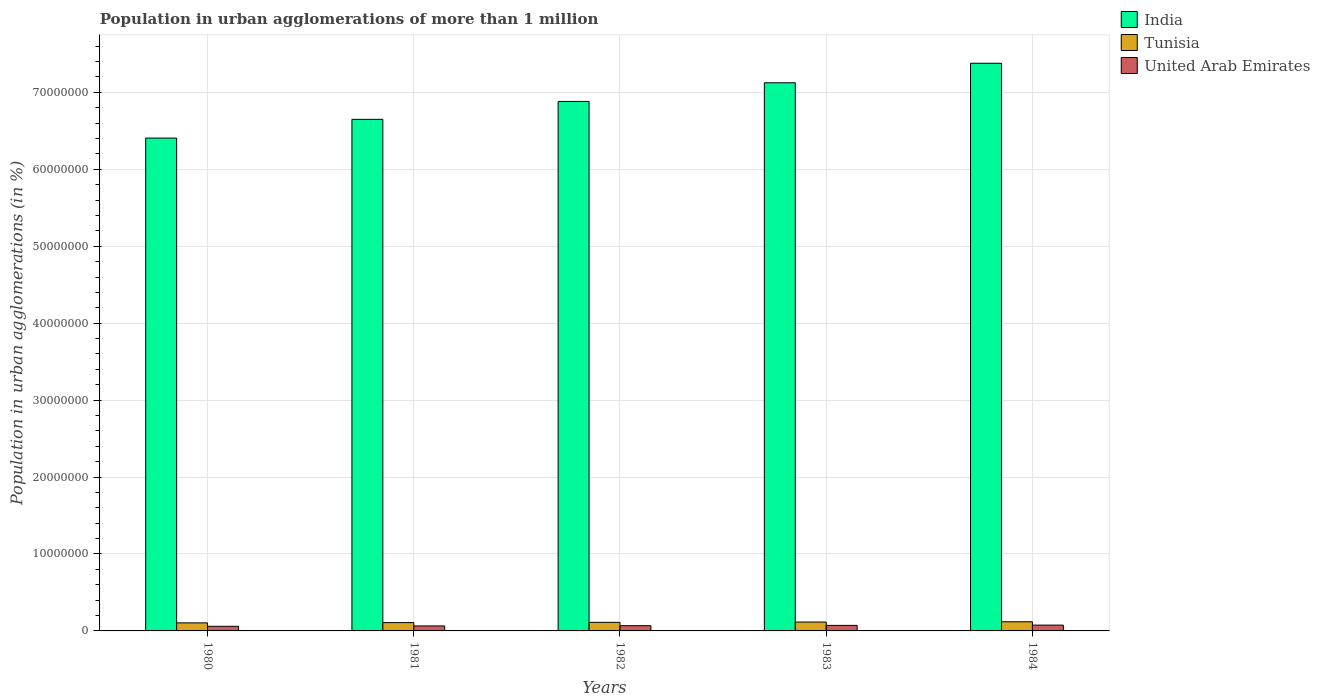How many different coloured bars are there?
Provide a succinct answer. 3. How many groups of bars are there?
Your answer should be compact. 5. What is the label of the 1st group of bars from the left?
Keep it short and to the point. 1980. In how many cases, is the number of bars for a given year not equal to the number of legend labels?
Your answer should be compact. 0. What is the population in urban agglomerations in Tunisia in 1982?
Your answer should be compact. 1.12e+06. Across all years, what is the maximum population in urban agglomerations in United Arab Emirates?
Your response must be concise. 7.54e+05. Across all years, what is the minimum population in urban agglomerations in United Arab Emirates?
Your answer should be compact. 6.00e+05. In which year was the population in urban agglomerations in United Arab Emirates maximum?
Offer a very short reply. 1984. In which year was the population in urban agglomerations in Tunisia minimum?
Offer a terse response. 1980. What is the total population in urban agglomerations in India in the graph?
Your response must be concise. 3.44e+08. What is the difference between the population in urban agglomerations in United Arab Emirates in 1982 and that in 1984?
Keep it short and to the point. -7.17e+04. What is the difference between the population in urban agglomerations in United Arab Emirates in 1981 and the population in urban agglomerations in Tunisia in 1980?
Your answer should be very brief. -3.98e+05. What is the average population in urban agglomerations in United Arab Emirates per year?
Offer a very short reply. 6.80e+05. In the year 1980, what is the difference between the population in urban agglomerations in Tunisia and population in urban agglomerations in United Arab Emirates?
Your answer should be compact. 4.47e+05. What is the ratio of the population in urban agglomerations in United Arab Emirates in 1980 to that in 1983?
Give a very brief answer. 0.84. What is the difference between the highest and the second highest population in urban agglomerations in United Arab Emirates?
Keep it short and to the point. 3.69e+04. What is the difference between the highest and the lowest population in urban agglomerations in Tunisia?
Give a very brief answer. 1.44e+05. In how many years, is the population in urban agglomerations in India greater than the average population in urban agglomerations in India taken over all years?
Provide a succinct answer. 2. Is the sum of the population in urban agglomerations in Tunisia in 1981 and 1982 greater than the maximum population in urban agglomerations in United Arab Emirates across all years?
Make the answer very short. Yes. What does the 2nd bar from the left in 1982 represents?
Offer a very short reply. Tunisia. What does the 1st bar from the right in 1983 represents?
Provide a succinct answer. United Arab Emirates. How many bars are there?
Keep it short and to the point. 15. What is the difference between two consecutive major ticks on the Y-axis?
Keep it short and to the point. 1.00e+07. Does the graph contain grids?
Your answer should be compact. Yes. How are the legend labels stacked?
Give a very brief answer. Vertical. What is the title of the graph?
Provide a short and direct response. Population in urban agglomerations of more than 1 million. Does "Swaziland" appear as one of the legend labels in the graph?
Give a very brief answer. No. What is the label or title of the X-axis?
Provide a succinct answer. Years. What is the label or title of the Y-axis?
Ensure brevity in your answer.  Population in urban agglomerations (in %). What is the Population in urban agglomerations (in %) in India in 1980?
Ensure brevity in your answer.  6.41e+07. What is the Population in urban agglomerations (in %) of Tunisia in 1980?
Provide a short and direct response. 1.05e+06. What is the Population in urban agglomerations (in %) of United Arab Emirates in 1980?
Make the answer very short. 6.00e+05. What is the Population in urban agglomerations (in %) in India in 1981?
Keep it short and to the point. 6.65e+07. What is the Population in urban agglomerations (in %) in Tunisia in 1981?
Provide a succinct answer. 1.08e+06. What is the Population in urban agglomerations (in %) of United Arab Emirates in 1981?
Your answer should be very brief. 6.49e+05. What is the Population in urban agglomerations (in %) of India in 1982?
Keep it short and to the point. 6.88e+07. What is the Population in urban agglomerations (in %) of Tunisia in 1982?
Your answer should be compact. 1.12e+06. What is the Population in urban agglomerations (in %) in United Arab Emirates in 1982?
Ensure brevity in your answer.  6.82e+05. What is the Population in urban agglomerations (in %) of India in 1983?
Keep it short and to the point. 7.12e+07. What is the Population in urban agglomerations (in %) of Tunisia in 1983?
Provide a succinct answer. 1.15e+06. What is the Population in urban agglomerations (in %) of United Arab Emirates in 1983?
Provide a succinct answer. 7.17e+05. What is the Population in urban agglomerations (in %) in India in 1984?
Your answer should be very brief. 7.38e+07. What is the Population in urban agglomerations (in %) in Tunisia in 1984?
Your answer should be compact. 1.19e+06. What is the Population in urban agglomerations (in %) of United Arab Emirates in 1984?
Your response must be concise. 7.54e+05. Across all years, what is the maximum Population in urban agglomerations (in %) of India?
Make the answer very short. 7.38e+07. Across all years, what is the maximum Population in urban agglomerations (in %) in Tunisia?
Give a very brief answer. 1.19e+06. Across all years, what is the maximum Population in urban agglomerations (in %) in United Arab Emirates?
Provide a short and direct response. 7.54e+05. Across all years, what is the minimum Population in urban agglomerations (in %) in India?
Offer a terse response. 6.41e+07. Across all years, what is the minimum Population in urban agglomerations (in %) of Tunisia?
Ensure brevity in your answer.  1.05e+06. Across all years, what is the minimum Population in urban agglomerations (in %) of United Arab Emirates?
Your answer should be compact. 6.00e+05. What is the total Population in urban agglomerations (in %) in India in the graph?
Offer a terse response. 3.44e+08. What is the total Population in urban agglomerations (in %) of Tunisia in the graph?
Make the answer very short. 5.59e+06. What is the total Population in urban agglomerations (in %) of United Arab Emirates in the graph?
Offer a very short reply. 3.40e+06. What is the difference between the Population in urban agglomerations (in %) of India in 1980 and that in 1981?
Offer a very short reply. -2.43e+06. What is the difference between the Population in urban agglomerations (in %) in Tunisia in 1980 and that in 1981?
Your answer should be very brief. -3.39e+04. What is the difference between the Population in urban agglomerations (in %) of United Arab Emirates in 1980 and that in 1981?
Give a very brief answer. -4.88e+04. What is the difference between the Population in urban agglomerations (in %) in India in 1980 and that in 1982?
Ensure brevity in your answer.  -4.76e+06. What is the difference between the Population in urban agglomerations (in %) of Tunisia in 1980 and that in 1982?
Your response must be concise. -6.89e+04. What is the difference between the Population in urban agglomerations (in %) in United Arab Emirates in 1980 and that in 1982?
Your response must be concise. -8.18e+04. What is the difference between the Population in urban agglomerations (in %) of India in 1980 and that in 1983?
Make the answer very short. -7.19e+06. What is the difference between the Population in urban agglomerations (in %) in Tunisia in 1980 and that in 1983?
Keep it short and to the point. -1.05e+05. What is the difference between the Population in urban agglomerations (in %) in United Arab Emirates in 1980 and that in 1983?
Keep it short and to the point. -1.17e+05. What is the difference between the Population in urban agglomerations (in %) of India in 1980 and that in 1984?
Provide a succinct answer. -9.72e+06. What is the difference between the Population in urban agglomerations (in %) in Tunisia in 1980 and that in 1984?
Offer a terse response. -1.44e+05. What is the difference between the Population in urban agglomerations (in %) in United Arab Emirates in 1980 and that in 1984?
Your response must be concise. -1.54e+05. What is the difference between the Population in urban agglomerations (in %) in India in 1981 and that in 1982?
Provide a succinct answer. -2.33e+06. What is the difference between the Population in urban agglomerations (in %) in Tunisia in 1981 and that in 1982?
Provide a short and direct response. -3.50e+04. What is the difference between the Population in urban agglomerations (in %) of United Arab Emirates in 1981 and that in 1982?
Offer a terse response. -3.30e+04. What is the difference between the Population in urban agglomerations (in %) in India in 1981 and that in 1983?
Provide a short and direct response. -4.75e+06. What is the difference between the Population in urban agglomerations (in %) in Tunisia in 1981 and that in 1983?
Offer a terse response. -7.12e+04. What is the difference between the Population in urban agglomerations (in %) of United Arab Emirates in 1981 and that in 1983?
Offer a very short reply. -6.79e+04. What is the difference between the Population in urban agglomerations (in %) of India in 1981 and that in 1984?
Your answer should be very brief. -7.29e+06. What is the difference between the Population in urban agglomerations (in %) in Tunisia in 1981 and that in 1984?
Keep it short and to the point. -1.10e+05. What is the difference between the Population in urban agglomerations (in %) in United Arab Emirates in 1981 and that in 1984?
Give a very brief answer. -1.05e+05. What is the difference between the Population in urban agglomerations (in %) of India in 1982 and that in 1983?
Your answer should be compact. -2.43e+06. What is the difference between the Population in urban agglomerations (in %) of Tunisia in 1982 and that in 1983?
Provide a short and direct response. -3.62e+04. What is the difference between the Population in urban agglomerations (in %) of United Arab Emirates in 1982 and that in 1983?
Offer a very short reply. -3.48e+04. What is the difference between the Population in urban agglomerations (in %) in India in 1982 and that in 1984?
Ensure brevity in your answer.  -4.96e+06. What is the difference between the Population in urban agglomerations (in %) of Tunisia in 1982 and that in 1984?
Provide a succinct answer. -7.46e+04. What is the difference between the Population in urban agglomerations (in %) of United Arab Emirates in 1982 and that in 1984?
Ensure brevity in your answer.  -7.17e+04. What is the difference between the Population in urban agglomerations (in %) of India in 1983 and that in 1984?
Keep it short and to the point. -2.53e+06. What is the difference between the Population in urban agglomerations (in %) of Tunisia in 1983 and that in 1984?
Keep it short and to the point. -3.84e+04. What is the difference between the Population in urban agglomerations (in %) in United Arab Emirates in 1983 and that in 1984?
Give a very brief answer. -3.69e+04. What is the difference between the Population in urban agglomerations (in %) of India in 1980 and the Population in urban agglomerations (in %) of Tunisia in 1981?
Ensure brevity in your answer.  6.30e+07. What is the difference between the Population in urban agglomerations (in %) of India in 1980 and the Population in urban agglomerations (in %) of United Arab Emirates in 1981?
Your answer should be compact. 6.34e+07. What is the difference between the Population in urban agglomerations (in %) of Tunisia in 1980 and the Population in urban agglomerations (in %) of United Arab Emirates in 1981?
Offer a very short reply. 3.98e+05. What is the difference between the Population in urban agglomerations (in %) of India in 1980 and the Population in urban agglomerations (in %) of Tunisia in 1982?
Your answer should be compact. 6.29e+07. What is the difference between the Population in urban agglomerations (in %) in India in 1980 and the Population in urban agglomerations (in %) in United Arab Emirates in 1982?
Offer a terse response. 6.34e+07. What is the difference between the Population in urban agglomerations (in %) in Tunisia in 1980 and the Population in urban agglomerations (in %) in United Arab Emirates in 1982?
Your answer should be very brief. 3.65e+05. What is the difference between the Population in urban agglomerations (in %) of India in 1980 and the Population in urban agglomerations (in %) of Tunisia in 1983?
Your response must be concise. 6.29e+07. What is the difference between the Population in urban agglomerations (in %) in India in 1980 and the Population in urban agglomerations (in %) in United Arab Emirates in 1983?
Your answer should be compact. 6.33e+07. What is the difference between the Population in urban agglomerations (in %) of Tunisia in 1980 and the Population in urban agglomerations (in %) of United Arab Emirates in 1983?
Provide a succinct answer. 3.30e+05. What is the difference between the Population in urban agglomerations (in %) in India in 1980 and the Population in urban agglomerations (in %) in Tunisia in 1984?
Offer a terse response. 6.29e+07. What is the difference between the Population in urban agglomerations (in %) in India in 1980 and the Population in urban agglomerations (in %) in United Arab Emirates in 1984?
Your response must be concise. 6.33e+07. What is the difference between the Population in urban agglomerations (in %) of Tunisia in 1980 and the Population in urban agglomerations (in %) of United Arab Emirates in 1984?
Ensure brevity in your answer.  2.93e+05. What is the difference between the Population in urban agglomerations (in %) of India in 1981 and the Population in urban agglomerations (in %) of Tunisia in 1982?
Make the answer very short. 6.54e+07. What is the difference between the Population in urban agglomerations (in %) of India in 1981 and the Population in urban agglomerations (in %) of United Arab Emirates in 1982?
Keep it short and to the point. 6.58e+07. What is the difference between the Population in urban agglomerations (in %) of Tunisia in 1981 and the Population in urban agglomerations (in %) of United Arab Emirates in 1982?
Offer a very short reply. 3.99e+05. What is the difference between the Population in urban agglomerations (in %) in India in 1981 and the Population in urban agglomerations (in %) in Tunisia in 1983?
Your answer should be very brief. 6.53e+07. What is the difference between the Population in urban agglomerations (in %) of India in 1981 and the Population in urban agglomerations (in %) of United Arab Emirates in 1983?
Offer a very short reply. 6.58e+07. What is the difference between the Population in urban agglomerations (in %) in Tunisia in 1981 and the Population in urban agglomerations (in %) in United Arab Emirates in 1983?
Keep it short and to the point. 3.64e+05. What is the difference between the Population in urban agglomerations (in %) in India in 1981 and the Population in urban agglomerations (in %) in Tunisia in 1984?
Give a very brief answer. 6.53e+07. What is the difference between the Population in urban agglomerations (in %) of India in 1981 and the Population in urban agglomerations (in %) of United Arab Emirates in 1984?
Ensure brevity in your answer.  6.57e+07. What is the difference between the Population in urban agglomerations (in %) of Tunisia in 1981 and the Population in urban agglomerations (in %) of United Arab Emirates in 1984?
Make the answer very short. 3.27e+05. What is the difference between the Population in urban agglomerations (in %) in India in 1982 and the Population in urban agglomerations (in %) in Tunisia in 1983?
Offer a terse response. 6.77e+07. What is the difference between the Population in urban agglomerations (in %) in India in 1982 and the Population in urban agglomerations (in %) in United Arab Emirates in 1983?
Your answer should be compact. 6.81e+07. What is the difference between the Population in urban agglomerations (in %) of Tunisia in 1982 and the Population in urban agglomerations (in %) of United Arab Emirates in 1983?
Your response must be concise. 3.99e+05. What is the difference between the Population in urban agglomerations (in %) in India in 1982 and the Population in urban agglomerations (in %) in Tunisia in 1984?
Your answer should be compact. 6.76e+07. What is the difference between the Population in urban agglomerations (in %) in India in 1982 and the Population in urban agglomerations (in %) in United Arab Emirates in 1984?
Your answer should be very brief. 6.81e+07. What is the difference between the Population in urban agglomerations (in %) in Tunisia in 1982 and the Population in urban agglomerations (in %) in United Arab Emirates in 1984?
Your answer should be compact. 3.62e+05. What is the difference between the Population in urban agglomerations (in %) in India in 1983 and the Population in urban agglomerations (in %) in Tunisia in 1984?
Make the answer very short. 7.01e+07. What is the difference between the Population in urban agglomerations (in %) in India in 1983 and the Population in urban agglomerations (in %) in United Arab Emirates in 1984?
Your response must be concise. 7.05e+07. What is the difference between the Population in urban agglomerations (in %) in Tunisia in 1983 and the Population in urban agglomerations (in %) in United Arab Emirates in 1984?
Your response must be concise. 3.99e+05. What is the average Population in urban agglomerations (in %) in India per year?
Make the answer very short. 6.89e+07. What is the average Population in urban agglomerations (in %) in Tunisia per year?
Offer a very short reply. 1.12e+06. What is the average Population in urban agglomerations (in %) in United Arab Emirates per year?
Your answer should be compact. 6.80e+05. In the year 1980, what is the difference between the Population in urban agglomerations (in %) in India and Population in urban agglomerations (in %) in Tunisia?
Your response must be concise. 6.30e+07. In the year 1980, what is the difference between the Population in urban agglomerations (in %) in India and Population in urban agglomerations (in %) in United Arab Emirates?
Offer a terse response. 6.35e+07. In the year 1980, what is the difference between the Population in urban agglomerations (in %) of Tunisia and Population in urban agglomerations (in %) of United Arab Emirates?
Provide a succinct answer. 4.47e+05. In the year 1981, what is the difference between the Population in urban agglomerations (in %) of India and Population in urban agglomerations (in %) of Tunisia?
Give a very brief answer. 6.54e+07. In the year 1981, what is the difference between the Population in urban agglomerations (in %) in India and Population in urban agglomerations (in %) in United Arab Emirates?
Your response must be concise. 6.58e+07. In the year 1981, what is the difference between the Population in urban agglomerations (in %) in Tunisia and Population in urban agglomerations (in %) in United Arab Emirates?
Keep it short and to the point. 4.32e+05. In the year 1982, what is the difference between the Population in urban agglomerations (in %) of India and Population in urban agglomerations (in %) of Tunisia?
Offer a very short reply. 6.77e+07. In the year 1982, what is the difference between the Population in urban agglomerations (in %) of India and Population in urban agglomerations (in %) of United Arab Emirates?
Your answer should be compact. 6.81e+07. In the year 1982, what is the difference between the Population in urban agglomerations (in %) in Tunisia and Population in urban agglomerations (in %) in United Arab Emirates?
Offer a terse response. 4.34e+05. In the year 1983, what is the difference between the Population in urban agglomerations (in %) of India and Population in urban agglomerations (in %) of Tunisia?
Provide a short and direct response. 7.01e+07. In the year 1983, what is the difference between the Population in urban agglomerations (in %) in India and Population in urban agglomerations (in %) in United Arab Emirates?
Keep it short and to the point. 7.05e+07. In the year 1983, what is the difference between the Population in urban agglomerations (in %) in Tunisia and Population in urban agglomerations (in %) in United Arab Emirates?
Your answer should be very brief. 4.35e+05. In the year 1984, what is the difference between the Population in urban agglomerations (in %) of India and Population in urban agglomerations (in %) of Tunisia?
Ensure brevity in your answer.  7.26e+07. In the year 1984, what is the difference between the Population in urban agglomerations (in %) of India and Population in urban agglomerations (in %) of United Arab Emirates?
Offer a very short reply. 7.30e+07. In the year 1984, what is the difference between the Population in urban agglomerations (in %) of Tunisia and Population in urban agglomerations (in %) of United Arab Emirates?
Offer a very short reply. 4.37e+05. What is the ratio of the Population in urban agglomerations (in %) in India in 1980 to that in 1981?
Keep it short and to the point. 0.96. What is the ratio of the Population in urban agglomerations (in %) in Tunisia in 1980 to that in 1981?
Make the answer very short. 0.97. What is the ratio of the Population in urban agglomerations (in %) of United Arab Emirates in 1980 to that in 1981?
Offer a very short reply. 0.92. What is the ratio of the Population in urban agglomerations (in %) in India in 1980 to that in 1982?
Provide a succinct answer. 0.93. What is the ratio of the Population in urban agglomerations (in %) in Tunisia in 1980 to that in 1982?
Give a very brief answer. 0.94. What is the ratio of the Population in urban agglomerations (in %) of United Arab Emirates in 1980 to that in 1982?
Make the answer very short. 0.88. What is the ratio of the Population in urban agglomerations (in %) of India in 1980 to that in 1983?
Your answer should be very brief. 0.9. What is the ratio of the Population in urban agglomerations (in %) of Tunisia in 1980 to that in 1983?
Provide a succinct answer. 0.91. What is the ratio of the Population in urban agglomerations (in %) of United Arab Emirates in 1980 to that in 1983?
Provide a succinct answer. 0.84. What is the ratio of the Population in urban agglomerations (in %) in India in 1980 to that in 1984?
Make the answer very short. 0.87. What is the ratio of the Population in urban agglomerations (in %) of Tunisia in 1980 to that in 1984?
Offer a terse response. 0.88. What is the ratio of the Population in urban agglomerations (in %) in United Arab Emirates in 1980 to that in 1984?
Keep it short and to the point. 0.8. What is the ratio of the Population in urban agglomerations (in %) in India in 1981 to that in 1982?
Provide a short and direct response. 0.97. What is the ratio of the Population in urban agglomerations (in %) of Tunisia in 1981 to that in 1982?
Provide a succinct answer. 0.97. What is the ratio of the Population in urban agglomerations (in %) in United Arab Emirates in 1981 to that in 1982?
Provide a succinct answer. 0.95. What is the ratio of the Population in urban agglomerations (in %) of Tunisia in 1981 to that in 1983?
Offer a terse response. 0.94. What is the ratio of the Population in urban agglomerations (in %) of United Arab Emirates in 1981 to that in 1983?
Keep it short and to the point. 0.91. What is the ratio of the Population in urban agglomerations (in %) of India in 1981 to that in 1984?
Ensure brevity in your answer.  0.9. What is the ratio of the Population in urban agglomerations (in %) of Tunisia in 1981 to that in 1984?
Your answer should be very brief. 0.91. What is the ratio of the Population in urban agglomerations (in %) of United Arab Emirates in 1981 to that in 1984?
Offer a very short reply. 0.86. What is the ratio of the Population in urban agglomerations (in %) of India in 1982 to that in 1983?
Give a very brief answer. 0.97. What is the ratio of the Population in urban agglomerations (in %) in Tunisia in 1982 to that in 1983?
Give a very brief answer. 0.97. What is the ratio of the Population in urban agglomerations (in %) of United Arab Emirates in 1982 to that in 1983?
Your answer should be very brief. 0.95. What is the ratio of the Population in urban agglomerations (in %) of India in 1982 to that in 1984?
Provide a short and direct response. 0.93. What is the ratio of the Population in urban agglomerations (in %) in Tunisia in 1982 to that in 1984?
Your answer should be compact. 0.94. What is the ratio of the Population in urban agglomerations (in %) in United Arab Emirates in 1982 to that in 1984?
Keep it short and to the point. 0.9. What is the ratio of the Population in urban agglomerations (in %) of India in 1983 to that in 1984?
Provide a succinct answer. 0.97. What is the ratio of the Population in urban agglomerations (in %) of United Arab Emirates in 1983 to that in 1984?
Make the answer very short. 0.95. What is the difference between the highest and the second highest Population in urban agglomerations (in %) of India?
Offer a terse response. 2.53e+06. What is the difference between the highest and the second highest Population in urban agglomerations (in %) of Tunisia?
Keep it short and to the point. 3.84e+04. What is the difference between the highest and the second highest Population in urban agglomerations (in %) of United Arab Emirates?
Offer a very short reply. 3.69e+04. What is the difference between the highest and the lowest Population in urban agglomerations (in %) in India?
Provide a short and direct response. 9.72e+06. What is the difference between the highest and the lowest Population in urban agglomerations (in %) in Tunisia?
Give a very brief answer. 1.44e+05. What is the difference between the highest and the lowest Population in urban agglomerations (in %) in United Arab Emirates?
Make the answer very short. 1.54e+05. 